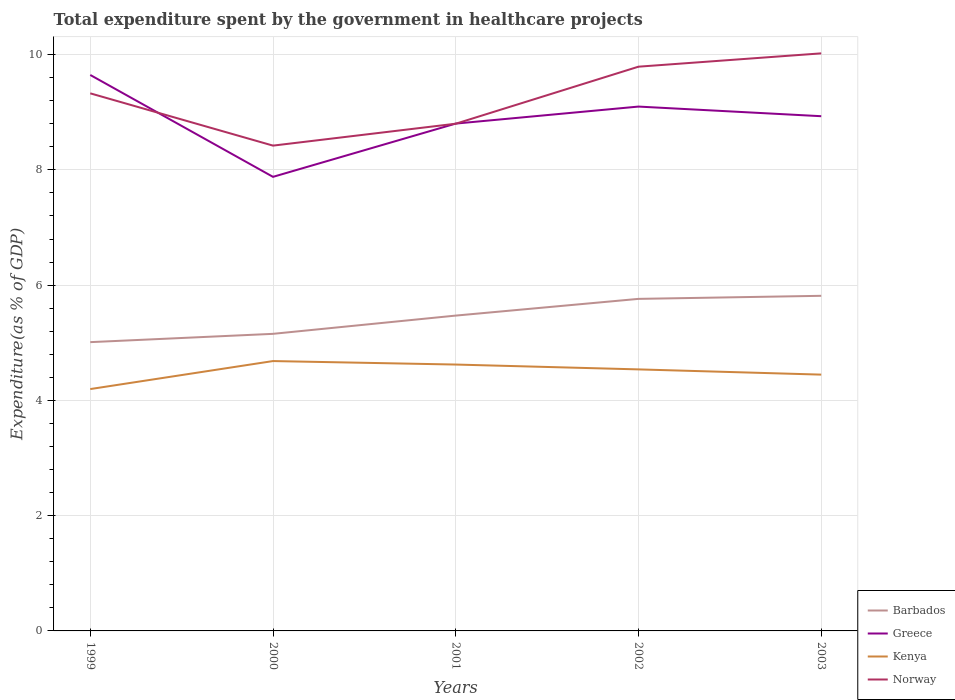Is the number of lines equal to the number of legend labels?
Keep it short and to the point. Yes. Across all years, what is the maximum total expenditure spent by the government in healthcare projects in Barbados?
Your answer should be very brief. 5.01. What is the total total expenditure spent by the government in healthcare projects in Barbados in the graph?
Offer a terse response. -0.75. What is the difference between the highest and the second highest total expenditure spent by the government in healthcare projects in Norway?
Your answer should be very brief. 1.6. What is the difference between the highest and the lowest total expenditure spent by the government in healthcare projects in Kenya?
Your answer should be very brief. 3. Is the total expenditure spent by the government in healthcare projects in Greece strictly greater than the total expenditure spent by the government in healthcare projects in Norway over the years?
Keep it short and to the point. No. How many lines are there?
Your answer should be very brief. 4. How many years are there in the graph?
Provide a succinct answer. 5. What is the difference between two consecutive major ticks on the Y-axis?
Your answer should be very brief. 2. Are the values on the major ticks of Y-axis written in scientific E-notation?
Give a very brief answer. No. Does the graph contain any zero values?
Ensure brevity in your answer.  No. Does the graph contain grids?
Your response must be concise. Yes. How many legend labels are there?
Provide a succinct answer. 4. How are the legend labels stacked?
Your response must be concise. Vertical. What is the title of the graph?
Provide a succinct answer. Total expenditure spent by the government in healthcare projects. What is the label or title of the X-axis?
Provide a succinct answer. Years. What is the label or title of the Y-axis?
Offer a terse response. Expenditure(as % of GDP). What is the Expenditure(as % of GDP) in Barbados in 1999?
Your response must be concise. 5.01. What is the Expenditure(as % of GDP) in Greece in 1999?
Make the answer very short. 9.65. What is the Expenditure(as % of GDP) in Kenya in 1999?
Offer a very short reply. 4.2. What is the Expenditure(as % of GDP) of Norway in 1999?
Provide a short and direct response. 9.33. What is the Expenditure(as % of GDP) of Barbados in 2000?
Offer a very short reply. 5.16. What is the Expenditure(as % of GDP) of Greece in 2000?
Provide a short and direct response. 7.88. What is the Expenditure(as % of GDP) in Kenya in 2000?
Ensure brevity in your answer.  4.68. What is the Expenditure(as % of GDP) of Norway in 2000?
Make the answer very short. 8.42. What is the Expenditure(as % of GDP) in Barbados in 2001?
Offer a terse response. 5.47. What is the Expenditure(as % of GDP) in Greece in 2001?
Provide a short and direct response. 8.8. What is the Expenditure(as % of GDP) of Kenya in 2001?
Your response must be concise. 4.62. What is the Expenditure(as % of GDP) in Norway in 2001?
Your response must be concise. 8.8. What is the Expenditure(as % of GDP) of Barbados in 2002?
Ensure brevity in your answer.  5.76. What is the Expenditure(as % of GDP) in Greece in 2002?
Ensure brevity in your answer.  9.1. What is the Expenditure(as % of GDP) in Kenya in 2002?
Keep it short and to the point. 4.54. What is the Expenditure(as % of GDP) of Norway in 2002?
Your response must be concise. 9.79. What is the Expenditure(as % of GDP) in Barbados in 2003?
Give a very brief answer. 5.82. What is the Expenditure(as % of GDP) of Greece in 2003?
Keep it short and to the point. 8.93. What is the Expenditure(as % of GDP) in Kenya in 2003?
Provide a short and direct response. 4.45. What is the Expenditure(as % of GDP) of Norway in 2003?
Provide a succinct answer. 10.02. Across all years, what is the maximum Expenditure(as % of GDP) of Barbados?
Your answer should be compact. 5.82. Across all years, what is the maximum Expenditure(as % of GDP) of Greece?
Your response must be concise. 9.65. Across all years, what is the maximum Expenditure(as % of GDP) in Kenya?
Offer a terse response. 4.68. Across all years, what is the maximum Expenditure(as % of GDP) of Norway?
Offer a very short reply. 10.02. Across all years, what is the minimum Expenditure(as % of GDP) of Barbados?
Offer a very short reply. 5.01. Across all years, what is the minimum Expenditure(as % of GDP) of Greece?
Keep it short and to the point. 7.88. Across all years, what is the minimum Expenditure(as % of GDP) of Kenya?
Your answer should be compact. 4.2. Across all years, what is the minimum Expenditure(as % of GDP) of Norway?
Offer a terse response. 8.42. What is the total Expenditure(as % of GDP) in Barbados in the graph?
Your answer should be very brief. 27.21. What is the total Expenditure(as % of GDP) in Greece in the graph?
Provide a succinct answer. 44.36. What is the total Expenditure(as % of GDP) of Kenya in the graph?
Keep it short and to the point. 22.49. What is the total Expenditure(as % of GDP) of Norway in the graph?
Provide a short and direct response. 46.36. What is the difference between the Expenditure(as % of GDP) of Barbados in 1999 and that in 2000?
Your answer should be very brief. -0.14. What is the difference between the Expenditure(as % of GDP) in Greece in 1999 and that in 2000?
Offer a terse response. 1.77. What is the difference between the Expenditure(as % of GDP) in Kenya in 1999 and that in 2000?
Provide a short and direct response. -0.49. What is the difference between the Expenditure(as % of GDP) in Norway in 1999 and that in 2000?
Ensure brevity in your answer.  0.91. What is the difference between the Expenditure(as % of GDP) in Barbados in 1999 and that in 2001?
Ensure brevity in your answer.  -0.46. What is the difference between the Expenditure(as % of GDP) of Greece in 1999 and that in 2001?
Your answer should be very brief. 0.84. What is the difference between the Expenditure(as % of GDP) in Kenya in 1999 and that in 2001?
Your answer should be compact. -0.43. What is the difference between the Expenditure(as % of GDP) of Norway in 1999 and that in 2001?
Provide a short and direct response. 0.53. What is the difference between the Expenditure(as % of GDP) of Barbados in 1999 and that in 2002?
Make the answer very short. -0.75. What is the difference between the Expenditure(as % of GDP) of Greece in 1999 and that in 2002?
Offer a terse response. 0.55. What is the difference between the Expenditure(as % of GDP) in Kenya in 1999 and that in 2002?
Make the answer very short. -0.34. What is the difference between the Expenditure(as % of GDP) in Norway in 1999 and that in 2002?
Your answer should be compact. -0.46. What is the difference between the Expenditure(as % of GDP) in Barbados in 1999 and that in 2003?
Offer a terse response. -0.8. What is the difference between the Expenditure(as % of GDP) in Greece in 1999 and that in 2003?
Provide a succinct answer. 0.72. What is the difference between the Expenditure(as % of GDP) in Kenya in 1999 and that in 2003?
Provide a short and direct response. -0.25. What is the difference between the Expenditure(as % of GDP) in Norway in 1999 and that in 2003?
Offer a terse response. -0.69. What is the difference between the Expenditure(as % of GDP) of Barbados in 2000 and that in 2001?
Keep it short and to the point. -0.32. What is the difference between the Expenditure(as % of GDP) of Greece in 2000 and that in 2001?
Offer a very short reply. -0.92. What is the difference between the Expenditure(as % of GDP) in Kenya in 2000 and that in 2001?
Provide a short and direct response. 0.06. What is the difference between the Expenditure(as % of GDP) in Norway in 2000 and that in 2001?
Provide a short and direct response. -0.38. What is the difference between the Expenditure(as % of GDP) of Barbados in 2000 and that in 2002?
Your response must be concise. -0.61. What is the difference between the Expenditure(as % of GDP) of Greece in 2000 and that in 2002?
Offer a very short reply. -1.22. What is the difference between the Expenditure(as % of GDP) in Kenya in 2000 and that in 2002?
Your answer should be very brief. 0.14. What is the difference between the Expenditure(as % of GDP) of Norway in 2000 and that in 2002?
Your answer should be very brief. -1.37. What is the difference between the Expenditure(as % of GDP) of Barbados in 2000 and that in 2003?
Offer a terse response. -0.66. What is the difference between the Expenditure(as % of GDP) of Greece in 2000 and that in 2003?
Give a very brief answer. -1.05. What is the difference between the Expenditure(as % of GDP) of Kenya in 2000 and that in 2003?
Keep it short and to the point. 0.24. What is the difference between the Expenditure(as % of GDP) in Norway in 2000 and that in 2003?
Make the answer very short. -1.6. What is the difference between the Expenditure(as % of GDP) of Barbados in 2001 and that in 2002?
Your response must be concise. -0.29. What is the difference between the Expenditure(as % of GDP) of Greece in 2001 and that in 2002?
Provide a succinct answer. -0.3. What is the difference between the Expenditure(as % of GDP) in Kenya in 2001 and that in 2002?
Provide a succinct answer. 0.08. What is the difference between the Expenditure(as % of GDP) of Norway in 2001 and that in 2002?
Your answer should be very brief. -0.99. What is the difference between the Expenditure(as % of GDP) of Barbados in 2001 and that in 2003?
Keep it short and to the point. -0.34. What is the difference between the Expenditure(as % of GDP) of Greece in 2001 and that in 2003?
Ensure brevity in your answer.  -0.13. What is the difference between the Expenditure(as % of GDP) of Kenya in 2001 and that in 2003?
Keep it short and to the point. 0.17. What is the difference between the Expenditure(as % of GDP) of Norway in 2001 and that in 2003?
Your answer should be compact. -1.22. What is the difference between the Expenditure(as % of GDP) in Barbados in 2002 and that in 2003?
Provide a succinct answer. -0.05. What is the difference between the Expenditure(as % of GDP) of Greece in 2002 and that in 2003?
Keep it short and to the point. 0.17. What is the difference between the Expenditure(as % of GDP) in Kenya in 2002 and that in 2003?
Your answer should be compact. 0.09. What is the difference between the Expenditure(as % of GDP) of Norway in 2002 and that in 2003?
Provide a short and direct response. -0.23. What is the difference between the Expenditure(as % of GDP) in Barbados in 1999 and the Expenditure(as % of GDP) in Greece in 2000?
Ensure brevity in your answer.  -2.87. What is the difference between the Expenditure(as % of GDP) of Barbados in 1999 and the Expenditure(as % of GDP) of Kenya in 2000?
Keep it short and to the point. 0.33. What is the difference between the Expenditure(as % of GDP) of Barbados in 1999 and the Expenditure(as % of GDP) of Norway in 2000?
Give a very brief answer. -3.41. What is the difference between the Expenditure(as % of GDP) of Greece in 1999 and the Expenditure(as % of GDP) of Kenya in 2000?
Offer a very short reply. 4.96. What is the difference between the Expenditure(as % of GDP) in Greece in 1999 and the Expenditure(as % of GDP) in Norway in 2000?
Provide a short and direct response. 1.23. What is the difference between the Expenditure(as % of GDP) in Kenya in 1999 and the Expenditure(as % of GDP) in Norway in 2000?
Make the answer very short. -4.22. What is the difference between the Expenditure(as % of GDP) of Barbados in 1999 and the Expenditure(as % of GDP) of Greece in 2001?
Give a very brief answer. -3.79. What is the difference between the Expenditure(as % of GDP) of Barbados in 1999 and the Expenditure(as % of GDP) of Kenya in 2001?
Make the answer very short. 0.39. What is the difference between the Expenditure(as % of GDP) in Barbados in 1999 and the Expenditure(as % of GDP) in Norway in 2001?
Offer a very short reply. -3.79. What is the difference between the Expenditure(as % of GDP) in Greece in 1999 and the Expenditure(as % of GDP) in Kenya in 2001?
Your response must be concise. 5.03. What is the difference between the Expenditure(as % of GDP) of Greece in 1999 and the Expenditure(as % of GDP) of Norway in 2001?
Offer a terse response. 0.85. What is the difference between the Expenditure(as % of GDP) of Kenya in 1999 and the Expenditure(as % of GDP) of Norway in 2001?
Keep it short and to the point. -4.6. What is the difference between the Expenditure(as % of GDP) in Barbados in 1999 and the Expenditure(as % of GDP) in Greece in 2002?
Your response must be concise. -4.09. What is the difference between the Expenditure(as % of GDP) in Barbados in 1999 and the Expenditure(as % of GDP) in Kenya in 2002?
Your answer should be very brief. 0.47. What is the difference between the Expenditure(as % of GDP) in Barbados in 1999 and the Expenditure(as % of GDP) in Norway in 2002?
Your answer should be compact. -4.78. What is the difference between the Expenditure(as % of GDP) of Greece in 1999 and the Expenditure(as % of GDP) of Kenya in 2002?
Ensure brevity in your answer.  5.11. What is the difference between the Expenditure(as % of GDP) in Greece in 1999 and the Expenditure(as % of GDP) in Norway in 2002?
Offer a very short reply. -0.14. What is the difference between the Expenditure(as % of GDP) of Kenya in 1999 and the Expenditure(as % of GDP) of Norway in 2002?
Your response must be concise. -5.59. What is the difference between the Expenditure(as % of GDP) in Barbados in 1999 and the Expenditure(as % of GDP) in Greece in 2003?
Provide a short and direct response. -3.92. What is the difference between the Expenditure(as % of GDP) in Barbados in 1999 and the Expenditure(as % of GDP) in Kenya in 2003?
Offer a very short reply. 0.56. What is the difference between the Expenditure(as % of GDP) of Barbados in 1999 and the Expenditure(as % of GDP) of Norway in 2003?
Provide a succinct answer. -5.01. What is the difference between the Expenditure(as % of GDP) of Greece in 1999 and the Expenditure(as % of GDP) of Kenya in 2003?
Provide a succinct answer. 5.2. What is the difference between the Expenditure(as % of GDP) in Greece in 1999 and the Expenditure(as % of GDP) in Norway in 2003?
Your response must be concise. -0.38. What is the difference between the Expenditure(as % of GDP) of Kenya in 1999 and the Expenditure(as % of GDP) of Norway in 2003?
Offer a terse response. -5.83. What is the difference between the Expenditure(as % of GDP) of Barbados in 2000 and the Expenditure(as % of GDP) of Greece in 2001?
Offer a very short reply. -3.65. What is the difference between the Expenditure(as % of GDP) in Barbados in 2000 and the Expenditure(as % of GDP) in Kenya in 2001?
Provide a short and direct response. 0.53. What is the difference between the Expenditure(as % of GDP) in Barbados in 2000 and the Expenditure(as % of GDP) in Norway in 2001?
Make the answer very short. -3.65. What is the difference between the Expenditure(as % of GDP) of Greece in 2000 and the Expenditure(as % of GDP) of Kenya in 2001?
Provide a succinct answer. 3.26. What is the difference between the Expenditure(as % of GDP) of Greece in 2000 and the Expenditure(as % of GDP) of Norway in 2001?
Make the answer very short. -0.92. What is the difference between the Expenditure(as % of GDP) in Kenya in 2000 and the Expenditure(as % of GDP) in Norway in 2001?
Your answer should be very brief. -4.12. What is the difference between the Expenditure(as % of GDP) of Barbados in 2000 and the Expenditure(as % of GDP) of Greece in 2002?
Make the answer very short. -3.94. What is the difference between the Expenditure(as % of GDP) of Barbados in 2000 and the Expenditure(as % of GDP) of Kenya in 2002?
Your response must be concise. 0.62. What is the difference between the Expenditure(as % of GDP) of Barbados in 2000 and the Expenditure(as % of GDP) of Norway in 2002?
Offer a very short reply. -4.64. What is the difference between the Expenditure(as % of GDP) of Greece in 2000 and the Expenditure(as % of GDP) of Kenya in 2002?
Make the answer very short. 3.34. What is the difference between the Expenditure(as % of GDP) of Greece in 2000 and the Expenditure(as % of GDP) of Norway in 2002?
Keep it short and to the point. -1.91. What is the difference between the Expenditure(as % of GDP) of Kenya in 2000 and the Expenditure(as % of GDP) of Norway in 2002?
Give a very brief answer. -5.11. What is the difference between the Expenditure(as % of GDP) of Barbados in 2000 and the Expenditure(as % of GDP) of Greece in 2003?
Your answer should be very brief. -3.78. What is the difference between the Expenditure(as % of GDP) of Barbados in 2000 and the Expenditure(as % of GDP) of Kenya in 2003?
Make the answer very short. 0.71. What is the difference between the Expenditure(as % of GDP) in Barbados in 2000 and the Expenditure(as % of GDP) in Norway in 2003?
Offer a very short reply. -4.87. What is the difference between the Expenditure(as % of GDP) of Greece in 2000 and the Expenditure(as % of GDP) of Kenya in 2003?
Ensure brevity in your answer.  3.43. What is the difference between the Expenditure(as % of GDP) in Greece in 2000 and the Expenditure(as % of GDP) in Norway in 2003?
Offer a terse response. -2.14. What is the difference between the Expenditure(as % of GDP) of Kenya in 2000 and the Expenditure(as % of GDP) of Norway in 2003?
Make the answer very short. -5.34. What is the difference between the Expenditure(as % of GDP) in Barbados in 2001 and the Expenditure(as % of GDP) in Greece in 2002?
Provide a short and direct response. -3.63. What is the difference between the Expenditure(as % of GDP) in Barbados in 2001 and the Expenditure(as % of GDP) in Kenya in 2002?
Provide a short and direct response. 0.93. What is the difference between the Expenditure(as % of GDP) in Barbados in 2001 and the Expenditure(as % of GDP) in Norway in 2002?
Your answer should be very brief. -4.32. What is the difference between the Expenditure(as % of GDP) in Greece in 2001 and the Expenditure(as % of GDP) in Kenya in 2002?
Provide a short and direct response. 4.27. What is the difference between the Expenditure(as % of GDP) in Greece in 2001 and the Expenditure(as % of GDP) in Norway in 2002?
Provide a short and direct response. -0.99. What is the difference between the Expenditure(as % of GDP) of Kenya in 2001 and the Expenditure(as % of GDP) of Norway in 2002?
Your answer should be compact. -5.17. What is the difference between the Expenditure(as % of GDP) of Barbados in 2001 and the Expenditure(as % of GDP) of Greece in 2003?
Your answer should be compact. -3.46. What is the difference between the Expenditure(as % of GDP) of Barbados in 2001 and the Expenditure(as % of GDP) of Kenya in 2003?
Your answer should be compact. 1.02. What is the difference between the Expenditure(as % of GDP) in Barbados in 2001 and the Expenditure(as % of GDP) in Norway in 2003?
Ensure brevity in your answer.  -4.55. What is the difference between the Expenditure(as % of GDP) of Greece in 2001 and the Expenditure(as % of GDP) of Kenya in 2003?
Offer a terse response. 4.36. What is the difference between the Expenditure(as % of GDP) of Greece in 2001 and the Expenditure(as % of GDP) of Norway in 2003?
Offer a terse response. -1.22. What is the difference between the Expenditure(as % of GDP) of Barbados in 2002 and the Expenditure(as % of GDP) of Greece in 2003?
Your answer should be compact. -3.17. What is the difference between the Expenditure(as % of GDP) in Barbados in 2002 and the Expenditure(as % of GDP) in Kenya in 2003?
Provide a short and direct response. 1.31. What is the difference between the Expenditure(as % of GDP) of Barbados in 2002 and the Expenditure(as % of GDP) of Norway in 2003?
Provide a short and direct response. -4.26. What is the difference between the Expenditure(as % of GDP) of Greece in 2002 and the Expenditure(as % of GDP) of Kenya in 2003?
Give a very brief answer. 4.65. What is the difference between the Expenditure(as % of GDP) of Greece in 2002 and the Expenditure(as % of GDP) of Norway in 2003?
Your answer should be compact. -0.92. What is the difference between the Expenditure(as % of GDP) of Kenya in 2002 and the Expenditure(as % of GDP) of Norway in 2003?
Give a very brief answer. -5.48. What is the average Expenditure(as % of GDP) of Barbados per year?
Your answer should be very brief. 5.44. What is the average Expenditure(as % of GDP) of Greece per year?
Your answer should be very brief. 8.87. What is the average Expenditure(as % of GDP) of Kenya per year?
Keep it short and to the point. 4.5. What is the average Expenditure(as % of GDP) of Norway per year?
Offer a terse response. 9.27. In the year 1999, what is the difference between the Expenditure(as % of GDP) in Barbados and Expenditure(as % of GDP) in Greece?
Make the answer very short. -4.64. In the year 1999, what is the difference between the Expenditure(as % of GDP) of Barbados and Expenditure(as % of GDP) of Kenya?
Keep it short and to the point. 0.81. In the year 1999, what is the difference between the Expenditure(as % of GDP) in Barbados and Expenditure(as % of GDP) in Norway?
Give a very brief answer. -4.32. In the year 1999, what is the difference between the Expenditure(as % of GDP) of Greece and Expenditure(as % of GDP) of Kenya?
Your answer should be compact. 5.45. In the year 1999, what is the difference between the Expenditure(as % of GDP) in Greece and Expenditure(as % of GDP) in Norway?
Provide a succinct answer. 0.32. In the year 1999, what is the difference between the Expenditure(as % of GDP) in Kenya and Expenditure(as % of GDP) in Norway?
Give a very brief answer. -5.13. In the year 2000, what is the difference between the Expenditure(as % of GDP) in Barbados and Expenditure(as % of GDP) in Greece?
Ensure brevity in your answer.  -2.72. In the year 2000, what is the difference between the Expenditure(as % of GDP) of Barbados and Expenditure(as % of GDP) of Kenya?
Your answer should be very brief. 0.47. In the year 2000, what is the difference between the Expenditure(as % of GDP) in Barbados and Expenditure(as % of GDP) in Norway?
Offer a very short reply. -3.27. In the year 2000, what is the difference between the Expenditure(as % of GDP) of Greece and Expenditure(as % of GDP) of Kenya?
Provide a short and direct response. 3.2. In the year 2000, what is the difference between the Expenditure(as % of GDP) of Greece and Expenditure(as % of GDP) of Norway?
Offer a very short reply. -0.54. In the year 2000, what is the difference between the Expenditure(as % of GDP) of Kenya and Expenditure(as % of GDP) of Norway?
Provide a short and direct response. -3.74. In the year 2001, what is the difference between the Expenditure(as % of GDP) of Barbados and Expenditure(as % of GDP) of Greece?
Your answer should be compact. -3.33. In the year 2001, what is the difference between the Expenditure(as % of GDP) of Barbados and Expenditure(as % of GDP) of Kenya?
Your answer should be very brief. 0.85. In the year 2001, what is the difference between the Expenditure(as % of GDP) in Barbados and Expenditure(as % of GDP) in Norway?
Give a very brief answer. -3.33. In the year 2001, what is the difference between the Expenditure(as % of GDP) of Greece and Expenditure(as % of GDP) of Kenya?
Ensure brevity in your answer.  4.18. In the year 2001, what is the difference between the Expenditure(as % of GDP) of Greece and Expenditure(as % of GDP) of Norway?
Give a very brief answer. 0. In the year 2001, what is the difference between the Expenditure(as % of GDP) of Kenya and Expenditure(as % of GDP) of Norway?
Keep it short and to the point. -4.18. In the year 2002, what is the difference between the Expenditure(as % of GDP) of Barbados and Expenditure(as % of GDP) of Greece?
Keep it short and to the point. -3.34. In the year 2002, what is the difference between the Expenditure(as % of GDP) in Barbados and Expenditure(as % of GDP) in Kenya?
Offer a very short reply. 1.22. In the year 2002, what is the difference between the Expenditure(as % of GDP) in Barbados and Expenditure(as % of GDP) in Norway?
Make the answer very short. -4.03. In the year 2002, what is the difference between the Expenditure(as % of GDP) in Greece and Expenditure(as % of GDP) in Kenya?
Keep it short and to the point. 4.56. In the year 2002, what is the difference between the Expenditure(as % of GDP) in Greece and Expenditure(as % of GDP) in Norway?
Offer a terse response. -0.69. In the year 2002, what is the difference between the Expenditure(as % of GDP) in Kenya and Expenditure(as % of GDP) in Norway?
Ensure brevity in your answer.  -5.25. In the year 2003, what is the difference between the Expenditure(as % of GDP) of Barbados and Expenditure(as % of GDP) of Greece?
Your answer should be very brief. -3.12. In the year 2003, what is the difference between the Expenditure(as % of GDP) in Barbados and Expenditure(as % of GDP) in Kenya?
Make the answer very short. 1.37. In the year 2003, what is the difference between the Expenditure(as % of GDP) of Barbados and Expenditure(as % of GDP) of Norway?
Provide a short and direct response. -4.21. In the year 2003, what is the difference between the Expenditure(as % of GDP) of Greece and Expenditure(as % of GDP) of Kenya?
Ensure brevity in your answer.  4.48. In the year 2003, what is the difference between the Expenditure(as % of GDP) in Greece and Expenditure(as % of GDP) in Norway?
Give a very brief answer. -1.09. In the year 2003, what is the difference between the Expenditure(as % of GDP) in Kenya and Expenditure(as % of GDP) in Norway?
Give a very brief answer. -5.57. What is the ratio of the Expenditure(as % of GDP) of Greece in 1999 to that in 2000?
Offer a terse response. 1.22. What is the ratio of the Expenditure(as % of GDP) in Kenya in 1999 to that in 2000?
Make the answer very short. 0.9. What is the ratio of the Expenditure(as % of GDP) in Norway in 1999 to that in 2000?
Give a very brief answer. 1.11. What is the ratio of the Expenditure(as % of GDP) of Barbados in 1999 to that in 2001?
Your answer should be compact. 0.92. What is the ratio of the Expenditure(as % of GDP) in Greece in 1999 to that in 2001?
Provide a succinct answer. 1.1. What is the ratio of the Expenditure(as % of GDP) in Kenya in 1999 to that in 2001?
Your answer should be very brief. 0.91. What is the ratio of the Expenditure(as % of GDP) in Norway in 1999 to that in 2001?
Your answer should be compact. 1.06. What is the ratio of the Expenditure(as % of GDP) of Barbados in 1999 to that in 2002?
Provide a short and direct response. 0.87. What is the ratio of the Expenditure(as % of GDP) in Greece in 1999 to that in 2002?
Your answer should be compact. 1.06. What is the ratio of the Expenditure(as % of GDP) of Kenya in 1999 to that in 2002?
Offer a terse response. 0.92. What is the ratio of the Expenditure(as % of GDP) in Norway in 1999 to that in 2002?
Provide a short and direct response. 0.95. What is the ratio of the Expenditure(as % of GDP) of Barbados in 1999 to that in 2003?
Offer a terse response. 0.86. What is the ratio of the Expenditure(as % of GDP) of Greece in 1999 to that in 2003?
Offer a terse response. 1.08. What is the ratio of the Expenditure(as % of GDP) in Kenya in 1999 to that in 2003?
Ensure brevity in your answer.  0.94. What is the ratio of the Expenditure(as % of GDP) in Norway in 1999 to that in 2003?
Your answer should be compact. 0.93. What is the ratio of the Expenditure(as % of GDP) in Barbados in 2000 to that in 2001?
Your answer should be very brief. 0.94. What is the ratio of the Expenditure(as % of GDP) of Greece in 2000 to that in 2001?
Provide a short and direct response. 0.9. What is the ratio of the Expenditure(as % of GDP) in Kenya in 2000 to that in 2001?
Offer a terse response. 1.01. What is the ratio of the Expenditure(as % of GDP) of Norway in 2000 to that in 2001?
Your answer should be compact. 0.96. What is the ratio of the Expenditure(as % of GDP) of Barbados in 2000 to that in 2002?
Offer a very short reply. 0.89. What is the ratio of the Expenditure(as % of GDP) in Greece in 2000 to that in 2002?
Your answer should be very brief. 0.87. What is the ratio of the Expenditure(as % of GDP) of Kenya in 2000 to that in 2002?
Offer a very short reply. 1.03. What is the ratio of the Expenditure(as % of GDP) in Norway in 2000 to that in 2002?
Make the answer very short. 0.86. What is the ratio of the Expenditure(as % of GDP) in Barbados in 2000 to that in 2003?
Provide a succinct answer. 0.89. What is the ratio of the Expenditure(as % of GDP) of Greece in 2000 to that in 2003?
Offer a very short reply. 0.88. What is the ratio of the Expenditure(as % of GDP) in Kenya in 2000 to that in 2003?
Offer a very short reply. 1.05. What is the ratio of the Expenditure(as % of GDP) in Norway in 2000 to that in 2003?
Provide a succinct answer. 0.84. What is the ratio of the Expenditure(as % of GDP) in Barbados in 2001 to that in 2002?
Your answer should be very brief. 0.95. What is the ratio of the Expenditure(as % of GDP) in Greece in 2001 to that in 2002?
Offer a terse response. 0.97. What is the ratio of the Expenditure(as % of GDP) in Kenya in 2001 to that in 2002?
Your response must be concise. 1.02. What is the ratio of the Expenditure(as % of GDP) of Norway in 2001 to that in 2002?
Your answer should be compact. 0.9. What is the ratio of the Expenditure(as % of GDP) of Barbados in 2001 to that in 2003?
Provide a short and direct response. 0.94. What is the ratio of the Expenditure(as % of GDP) of Greece in 2001 to that in 2003?
Provide a short and direct response. 0.99. What is the ratio of the Expenditure(as % of GDP) in Kenya in 2001 to that in 2003?
Offer a very short reply. 1.04. What is the ratio of the Expenditure(as % of GDP) of Norway in 2001 to that in 2003?
Offer a very short reply. 0.88. What is the ratio of the Expenditure(as % of GDP) of Barbados in 2002 to that in 2003?
Your answer should be compact. 0.99. What is the ratio of the Expenditure(as % of GDP) of Greece in 2002 to that in 2003?
Make the answer very short. 1.02. What is the ratio of the Expenditure(as % of GDP) of Kenya in 2002 to that in 2003?
Your answer should be compact. 1.02. What is the ratio of the Expenditure(as % of GDP) of Norway in 2002 to that in 2003?
Your response must be concise. 0.98. What is the difference between the highest and the second highest Expenditure(as % of GDP) in Barbados?
Your answer should be very brief. 0.05. What is the difference between the highest and the second highest Expenditure(as % of GDP) of Greece?
Provide a succinct answer. 0.55. What is the difference between the highest and the second highest Expenditure(as % of GDP) of Kenya?
Provide a short and direct response. 0.06. What is the difference between the highest and the second highest Expenditure(as % of GDP) of Norway?
Make the answer very short. 0.23. What is the difference between the highest and the lowest Expenditure(as % of GDP) in Barbados?
Provide a short and direct response. 0.8. What is the difference between the highest and the lowest Expenditure(as % of GDP) in Greece?
Ensure brevity in your answer.  1.77. What is the difference between the highest and the lowest Expenditure(as % of GDP) in Kenya?
Offer a very short reply. 0.49. What is the difference between the highest and the lowest Expenditure(as % of GDP) in Norway?
Provide a short and direct response. 1.6. 